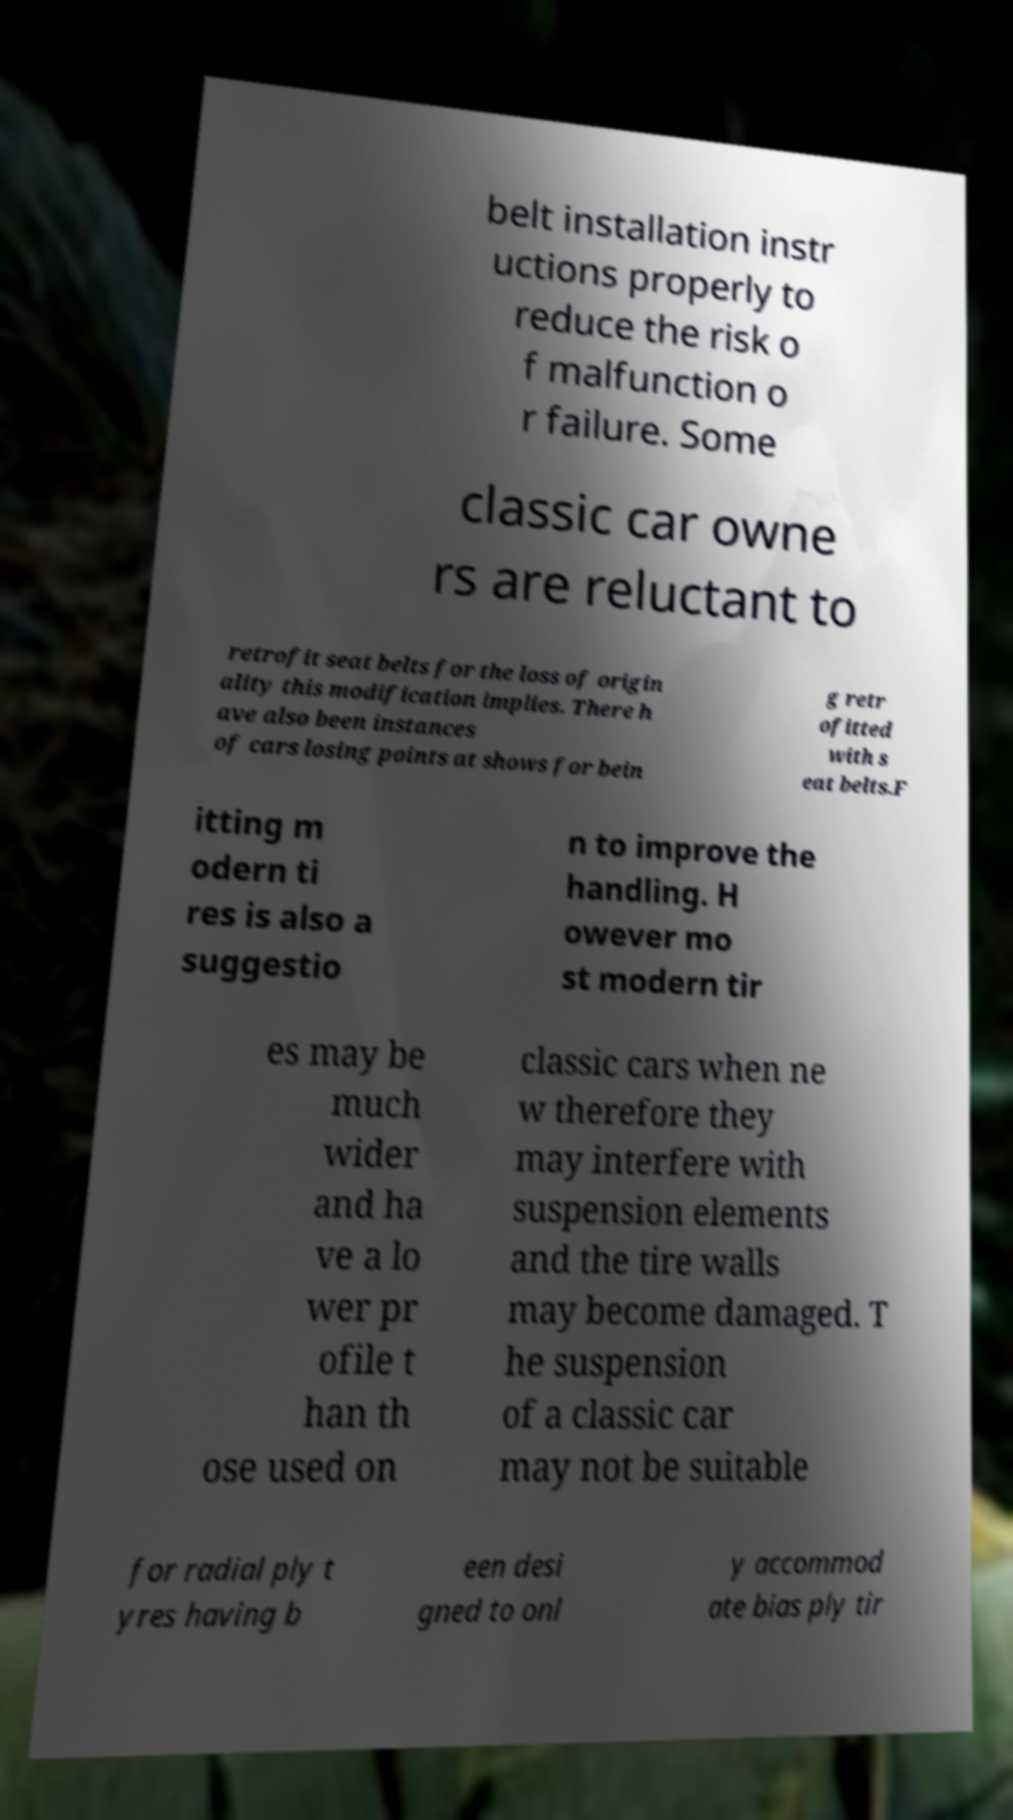What messages or text are displayed in this image? I need them in a readable, typed format. belt installation instr uctions properly to reduce the risk o f malfunction o r failure. Some classic car owne rs are reluctant to retrofit seat belts for the loss of origin ality this modification implies. There h ave also been instances of cars losing points at shows for bein g retr ofitted with s eat belts.F itting m odern ti res is also a suggestio n to improve the handling. H owever mo st modern tir es may be much wider and ha ve a lo wer pr ofile t han th ose used on classic cars when ne w therefore they may interfere with suspension elements and the tire walls may become damaged. T he suspension of a classic car may not be suitable for radial ply t yres having b een desi gned to onl y accommod ate bias ply tir 